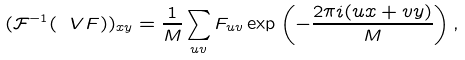<formula> <loc_0><loc_0><loc_500><loc_500>( \mathcal { F } ^ { - 1 } ( \ V { F } ) ) _ { x y } = \frac { 1 } { M } \sum _ { u v } F _ { u v } \exp \left ( - \frac { 2 \pi i ( u x + v y ) } { M } \right ) ,</formula> 